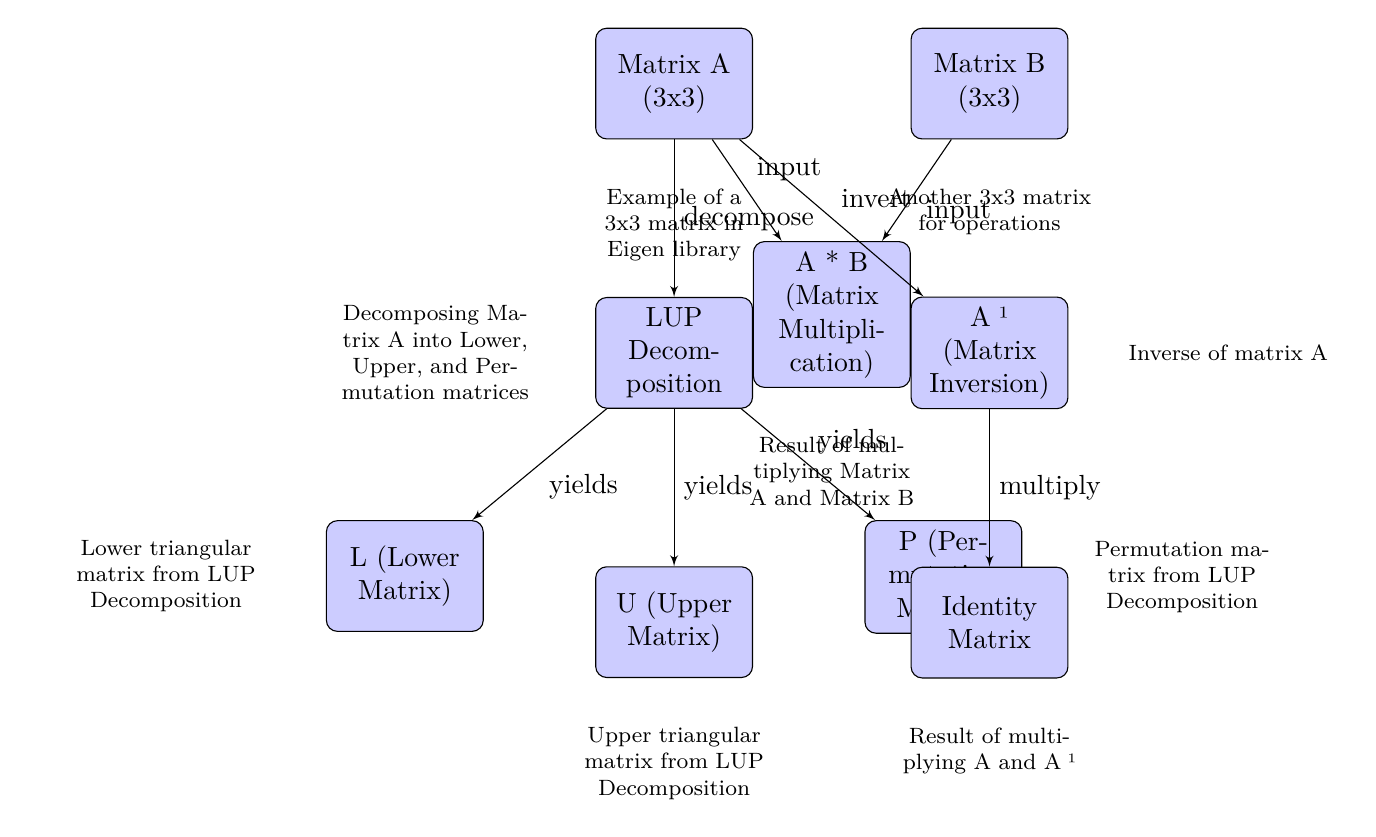What are the dimensions of Matrix A? The diagram explicitly states that Matrix A is a 3x3 matrix, which means it has 3 rows and 3 columns.
Answer: 3x3 What operation is represented between Matrix A and Matrix B? The diagram shows that Matrix A and Matrix B are used as inputs to produce a result through matrix multiplication.
Answer: Matrix Multiplication How many matrices are generated from LUP Decomposition? The diagram illustrates that from LUP Decomposition, three matrices are derived: L (Lower Matrix), U (Upper Matrix), and P (Permutation Matrix).
Answer: Three What is the result of multiplying Matrix A and the Inverse of Matrix A? According to the diagram, the result of multiplying Matrix A by its inverse (A⁻¹) yields the identity matrix.
Answer: Identity Matrix What type of matrix is produced by inverting Matrix A? The diagram indicates that the operation performed on Matrix A to produce its inverse results in A⁻¹, which is categorized as the inverse matrix.
Answer: Inverse Matrix What does the label 'yields' indicate between LUP Decomposition and its resulting matrices? The label 'yields' indicates that the process of LUP Decomposition produces or generates the output matrices: L, U, and P.
Answer: Produces What is the sequence of operations shown in the diagram starting from Matrix A? The sequence starts with Matrix A being decomposed into LUP, which then splits into the lower, upper, and permutation matrices, and finally, Matrix A is inverted to produce A⁻¹, which, when multiplied by A, results in the identity matrix.
Answer: Decompose, Invert, Multiply What type of matrix does the Lower Matrix represent? The diagram specifically describes the Lower Matrix as being lower triangular, which characterizes its structure.
Answer: Lower Triangular Matrix 